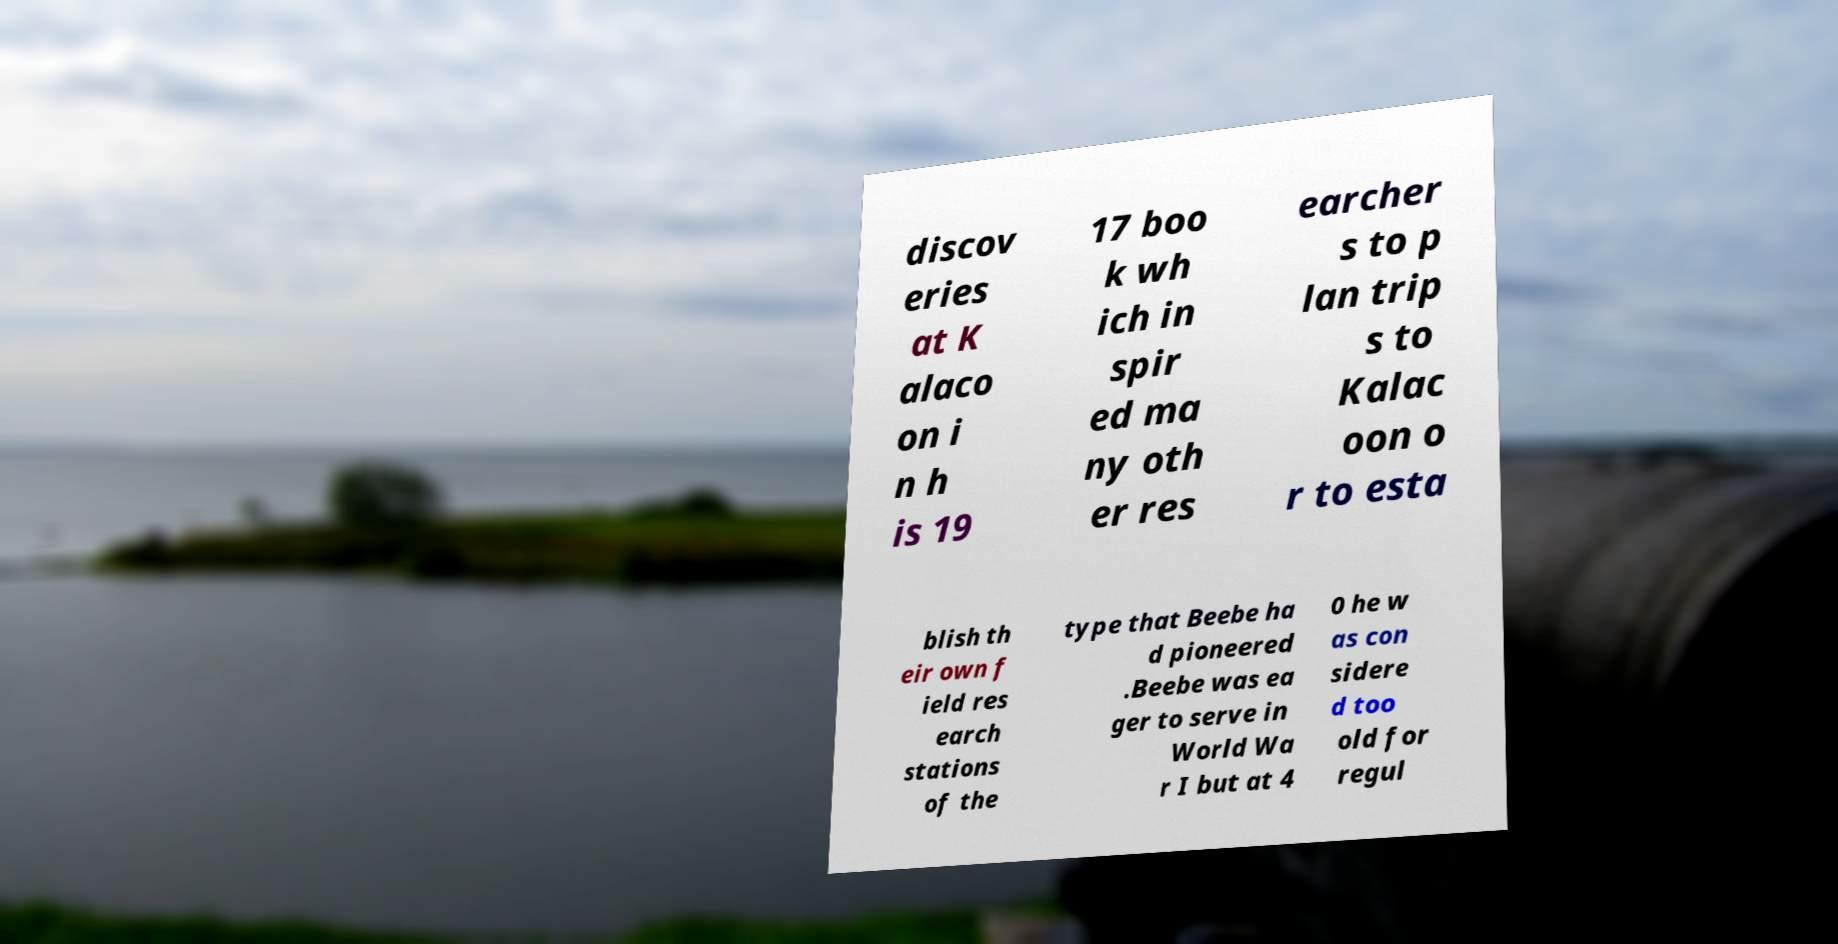I need the written content from this picture converted into text. Can you do that? discov eries at K alaco on i n h is 19 17 boo k wh ich in spir ed ma ny oth er res earcher s to p lan trip s to Kalac oon o r to esta blish th eir own f ield res earch stations of the type that Beebe ha d pioneered .Beebe was ea ger to serve in World Wa r I but at 4 0 he w as con sidere d too old for regul 